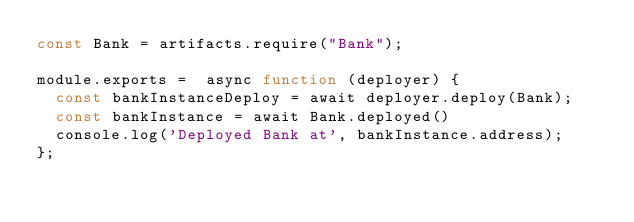<code> <loc_0><loc_0><loc_500><loc_500><_JavaScript_>const Bank = artifacts.require("Bank");

module.exports =  async function (deployer) {
  const bankInstanceDeploy = await deployer.deploy(Bank);
  const bankInstance = await Bank.deployed()
  console.log('Deployed Bank at', bankInstance.address);
};
</code> 